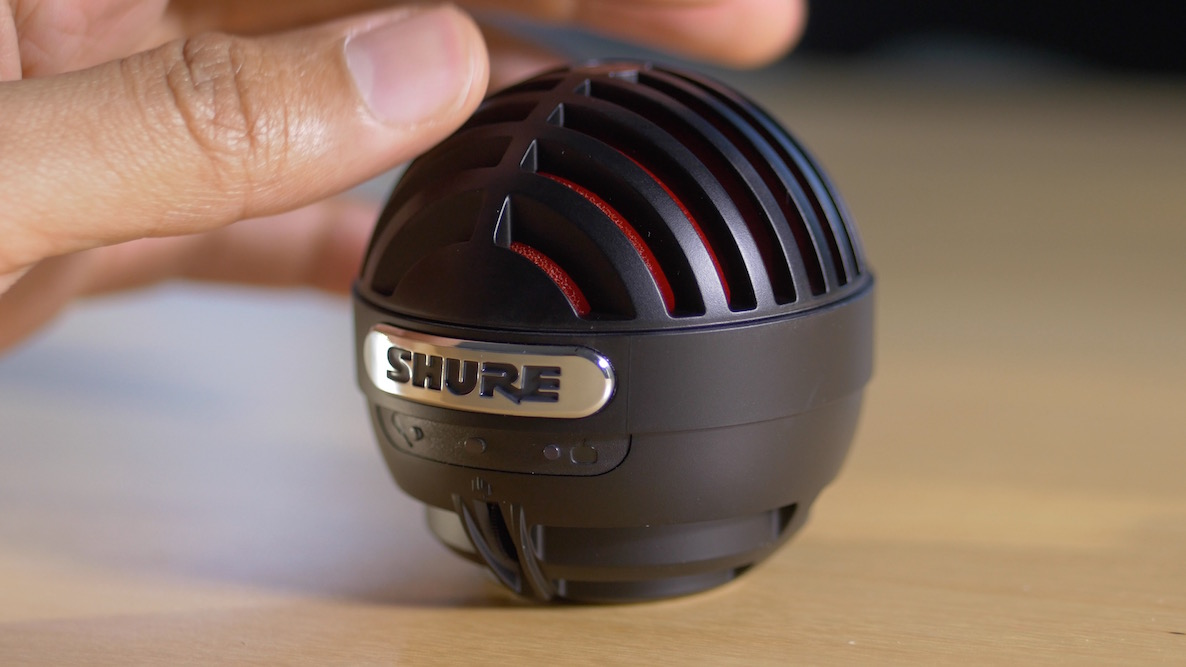Can you explain how the design of the microphone's grille contributes to its performance? The design of the microphone's grille plays a critical role in its performance. The spherical shape helps to diffuse incoming sound waves, minimizing directionality and ensuring more uniform sound capture. Additionally, the slotted pattern in the grille can aid in dispersing any wind or breath blasts, thereby lessening breath noises and further reducing plosive sounds when used without an external pop filter. This design enhances overall sound quality when recording in various conditions. 